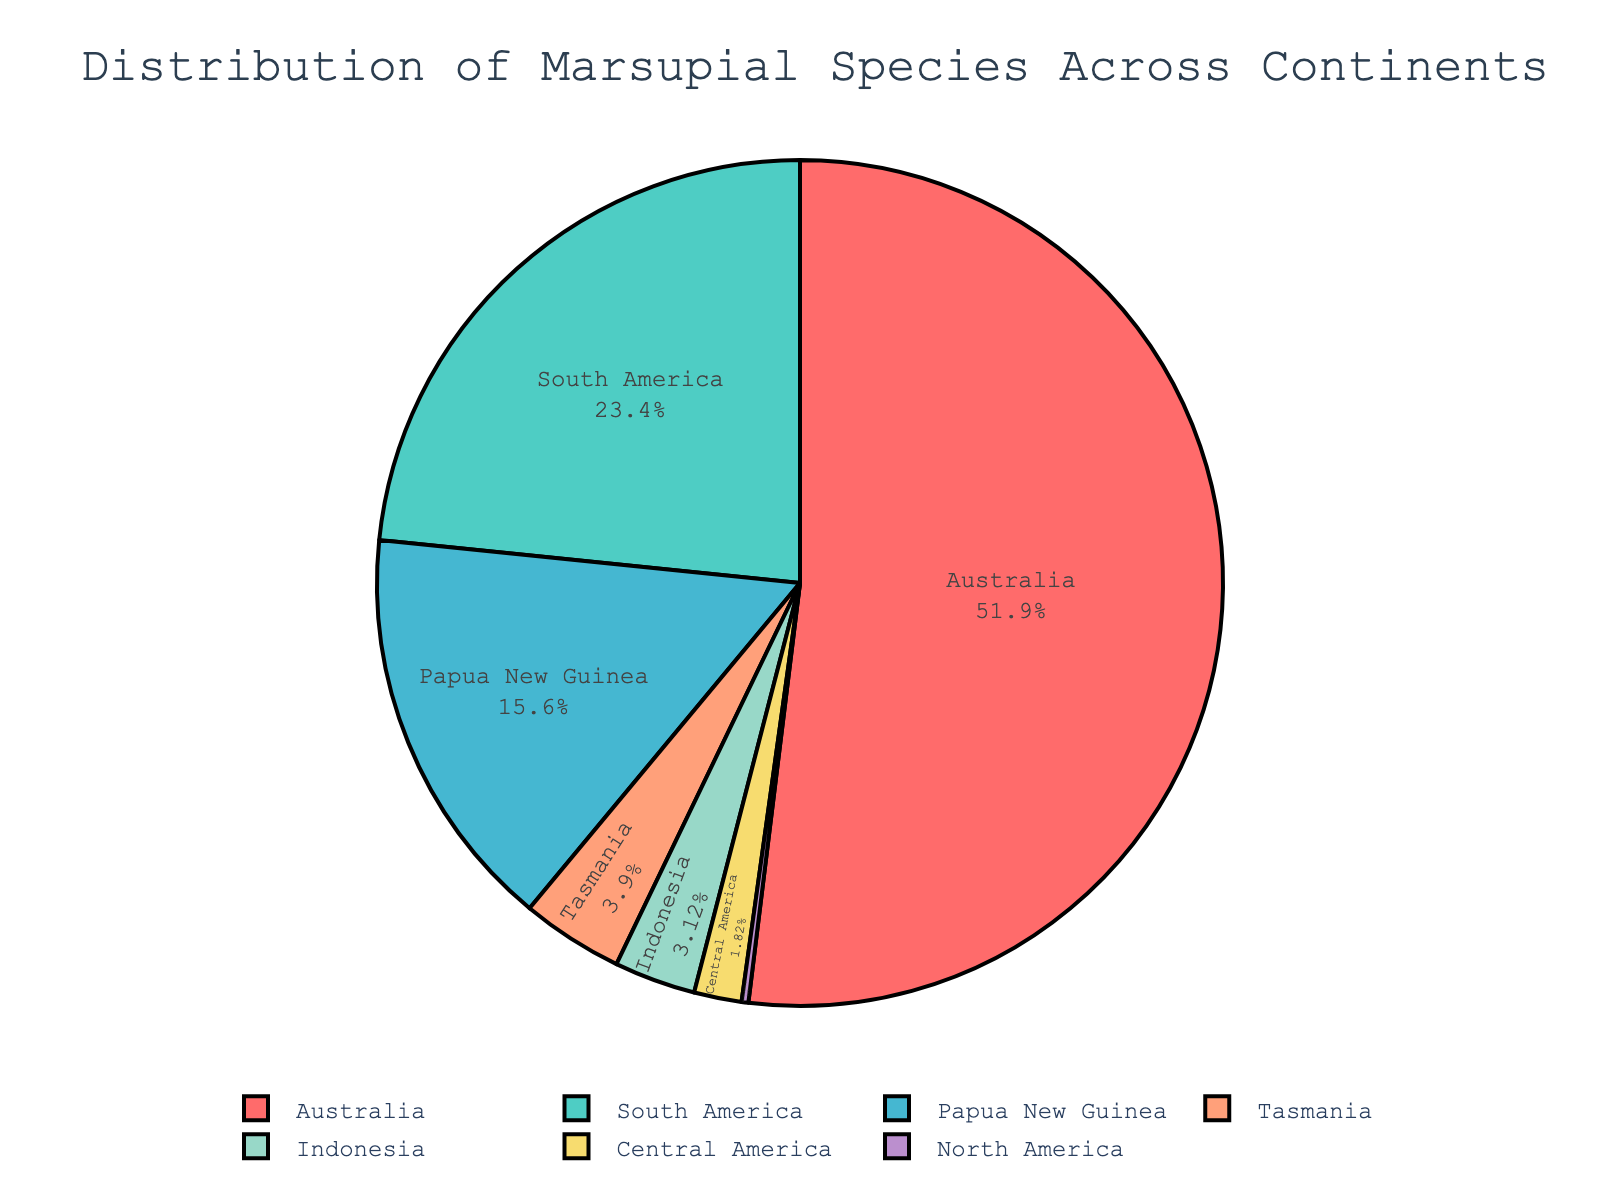What percentage of marsupial species are found in South America? Look at the segment labeled "South America" and read the percentage value displayed inside.
Answer: 26.6% Which continent has the smallest number of marsupial species? Identify the smallest segment in the pie chart and read its label.
Answer: North America How many more species are there in Papua New Guinea compared to Indonesia? Determine the number of species in both Papua New Guinea and Indonesia, then subtract the smaller value from the larger value: 60 - 12.
Answer: 48 Which continent, other than Australia, has the highest number of marsupial species? Identify the second largest segment after Australia and read its label.
Answer: South America How does the number of marsupial species in Central America compare to that in Tasmania? Compare the segments labeled "Central America" and "Tasmania" to see which is larger and by how much. Tasmania has 15 species, Central America has 7 species, so Tasmania has 8 more species.
Answer: 8 more in Tasmania What is the total number of marsupial species across all continents? Sum the number of species for all listed continents: 200 (Australia) + 90 (South America) + 1 (North America) + 60 (Papua New Guinea) + 12 (Indonesia) + 7 (Central America) + 15 (Tasmania).
Answer: 385 What proportion of marsupial species are found in Australia compared to the total number? Calculate the percentage by dividing the number of species in Australia by the total number: 200 / 385 * 100.
Answer: 51.9% What color represents Indonesia on the pie chart? Look at the legend to match the color associated with "Indonesia" to its segment in the pie chart.
Answer: Light Blue 